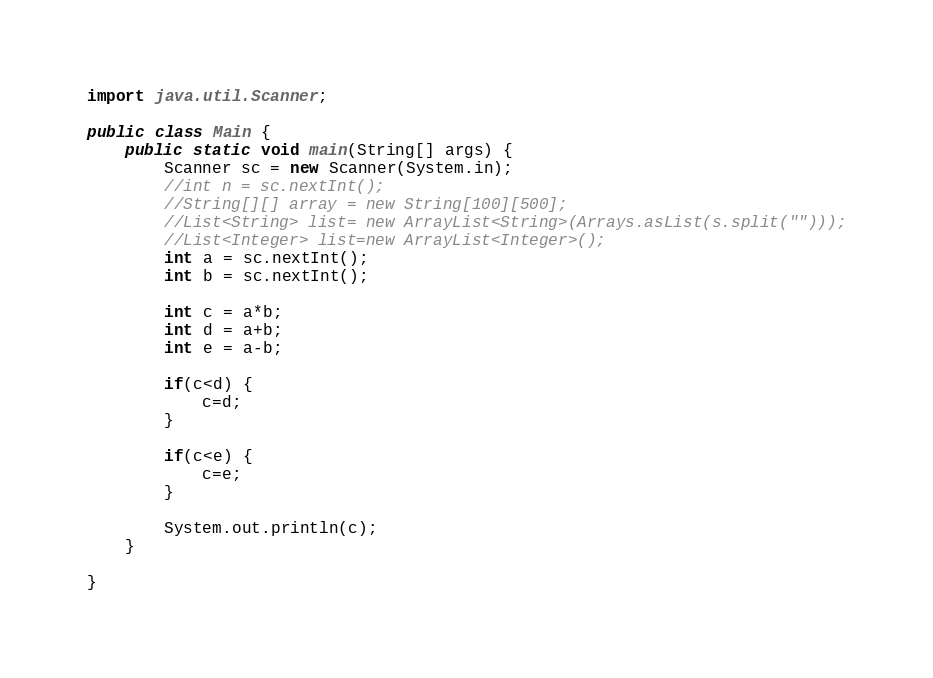Convert code to text. <code><loc_0><loc_0><loc_500><loc_500><_Java_>import java.util.Scanner;

public class Main {
	public static void main(String[] args) {
		Scanner sc = new Scanner(System.in);
		//int n = sc.nextInt();
		//String[][] array = new String[100][500];
		//List<String> list= new ArrayList<String>(Arrays.asList(s.split("")));
		//List<Integer> list=new ArrayList<Integer>();
		int a = sc.nextInt();
		int b = sc.nextInt();

		int c = a*b;
		int d = a+b;
		int e = a-b;

		if(c<d) {
			c=d;
		}

		if(c<e) {
			c=e;
		}

		System.out.println(c);
	}

}</code> 